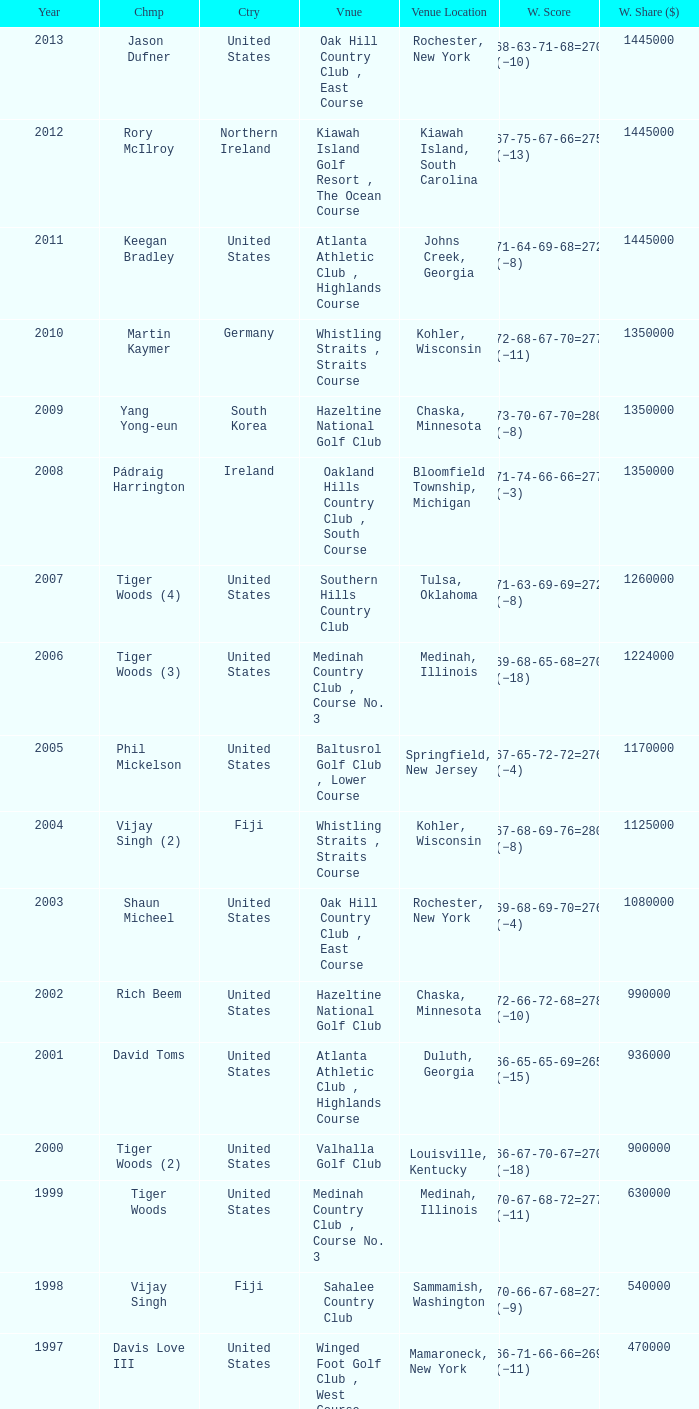Parse the table in full. {'header': ['Year', 'Chmp', 'Ctry', 'Vnue', 'Venue Location', 'W. Score', 'W. Share ($)'], 'rows': [['2013', 'Jason Dufner', 'United States', 'Oak Hill Country Club , East Course', 'Rochester, New York', '68-63-71-68=270 (−10)', '1445000'], ['2012', 'Rory McIlroy', 'Northern Ireland', 'Kiawah Island Golf Resort , The Ocean Course', 'Kiawah Island, South Carolina', '67-75-67-66=275 (−13)', '1445000'], ['2011', 'Keegan Bradley', 'United States', 'Atlanta Athletic Club , Highlands Course', 'Johns Creek, Georgia', '71-64-69-68=272 (−8)', '1445000'], ['2010', 'Martin Kaymer', 'Germany', 'Whistling Straits , Straits Course', 'Kohler, Wisconsin', '72-68-67-70=277 (−11)', '1350000'], ['2009', 'Yang Yong-eun', 'South Korea', 'Hazeltine National Golf Club', 'Chaska, Minnesota', '73-70-67-70=280 (−8)', '1350000'], ['2008', 'Pádraig Harrington', 'Ireland', 'Oakland Hills Country Club , South Course', 'Bloomfield Township, Michigan', '71-74-66-66=277 (−3)', '1350000'], ['2007', 'Tiger Woods (4)', 'United States', 'Southern Hills Country Club', 'Tulsa, Oklahoma', '71-63-69-69=272 (−8)', '1260000'], ['2006', 'Tiger Woods (3)', 'United States', 'Medinah Country Club , Course No. 3', 'Medinah, Illinois', '69-68-65-68=270 (−18)', '1224000'], ['2005', 'Phil Mickelson', 'United States', 'Baltusrol Golf Club , Lower Course', 'Springfield, New Jersey', '67-65-72-72=276 (−4)', '1170000'], ['2004', 'Vijay Singh (2)', 'Fiji', 'Whistling Straits , Straits Course', 'Kohler, Wisconsin', '67-68-69-76=280 (−8)', '1125000'], ['2003', 'Shaun Micheel', 'United States', 'Oak Hill Country Club , East Course', 'Rochester, New York', '69-68-69-70=276 (−4)', '1080000'], ['2002', 'Rich Beem', 'United States', 'Hazeltine National Golf Club', 'Chaska, Minnesota', '72-66-72-68=278 (−10)', '990000'], ['2001', 'David Toms', 'United States', 'Atlanta Athletic Club , Highlands Course', 'Duluth, Georgia', '66-65-65-69=265 (−15)', '936000'], ['2000', 'Tiger Woods (2)', 'United States', 'Valhalla Golf Club', 'Louisville, Kentucky', '66-67-70-67=270 (−18)', '900000'], ['1999', 'Tiger Woods', 'United States', 'Medinah Country Club , Course No. 3', 'Medinah, Illinois', '70-67-68-72=277 (−11)', '630000'], ['1998', 'Vijay Singh', 'Fiji', 'Sahalee Country Club', 'Sammamish, Washington', '70-66-67-68=271 (−9)', '540000'], ['1997', 'Davis Love III', 'United States', 'Winged Foot Golf Club , West Course', 'Mamaroneck, New York', '66-71-66-66=269 (−11)', '470000'], ['1996', 'Mark Brooks', 'United States', 'Valhalla Golf Club', 'Louisville, Kentucky', '68-70-69-70=277 (−11)', '430000'], ['1995', 'Steve Elkington', 'Australia', 'Riviera Country Club', 'Pacific Palisades, California', '68-67-68-64=267 (−17)', '360000'], ['1994', 'Nick Price (2)', 'Zimbabwe', 'Southern Hills Country Club', 'Tulsa, Oklahoma', '67-65-70-67=269 (−11)', '310000'], ['1993', 'Paul Azinger', 'United States', 'Inverness Club', 'Toledo, Ohio', '69-66-69-68=272 (−12)', '300000'], ['1992', 'Nick Price', 'Zimbabwe', 'Bellerive Country Club', 'St. Louis, Missouri', '70-70-68-70=278 (−6)', '280000'], ['1991', 'John Daly', 'United States', 'Crooked Stick Golf Club', 'Carmel, Indiana', '69-67-69-71=276 (−12)', '230000'], ['1990', 'Wayne Grady', 'Australia', 'Shoal Creek Golf and Country Club', 'Birmingham, Alabama', '72-67-72-71=282 (−6)', '225000'], ['1989', 'Payne Stewart', 'United States', 'Kemper Lakes Golf Club', 'Long Grove, Illinois', '74-66-69-67=276 (−12)', '200000'], ['1988', 'Jeff Sluman', 'United States', 'Oak Tree Golf Club', 'Edmond, Oklahoma', '69-70-68-65=272 (−12)', '160000'], ['1987', 'Larry Nelson (2)', 'United States', 'PGA National Resort & Spa', 'Palm Beach Gardens, Florida', '70-72-73-72=287 (−1)', '150000'], ['1986', 'Bob Tway', 'United States', 'Inverness Club', 'Toledo, Ohio', '72-70-64-70=276 (−8)', '145000'], ['1985', 'Hubert Green', 'United States', 'Cherry Hills Country Club', 'Cherry Hills Village, Colorado', '67-69-70-72=278 (−6)', '125000'], ['1984', 'Lee Trevino (2)', 'United States', 'Shoal Creek Golf and Country Club', 'Birmingham, Alabama', '69-68-67-69=273 (−15)', '125000'], ['1983', 'Hal Sutton', 'United States', 'Riviera Country Club', 'Pacific Palisades, California', '65-66-72-71=274 (−10)', '100000'], ['1982', 'Raymond Floyd (2)', 'United States', 'Southern Hills Country Club', 'Tulsa, Oklahoma', '63-69-68-72=272 (−8)', '65000'], ['1981', 'Larry Nelson', 'United States', 'Atlanta Athletic Club , Highlands Course', 'Duluth, Georgia', '70-66-66-71=273 (−7)', '60000'], ['1980', 'Jack Nicklaus (5)', 'United States', 'Oak Hill Country Club , East Course', 'Rochester, New York', '70-69-66-69=274 (−6)', '60000'], ['1979', 'David Graham', 'Australia', 'Oakland Hills Country Club , South Course', 'Bloomfield Township, Michigan', '69-68-70-65=272 (−8)', '60000'], ['1978', 'John Mahaffey', 'United States', 'Oakmont Country Club', 'Oakmont, Pennsylvania', '75-67-68-66=276 (−8)', '50000'], ['1977', 'Lanny Wadkins', 'United States', 'Pebble Beach Golf Links', 'Pebble Beach, California', '69-71-72-70=282 (−6)', '45000'], ['1976', 'Dave Stockton (2)', 'United States', 'Congressional Country Club , Blue Course', 'Bethesda, Maryland', '70-72-69-70=281 (+1)', '45000'], ['1975', 'Jack Nicklaus (4)', 'United States', 'Firestone Country Club , South Course', 'Akron, Ohio', '70-68-67-71=276 (−4)', '45000'], ['1974', 'Lee Trevino', 'United States', 'Tanglewood Park , Championship Course', 'Clemmons, North Carolina', '73-66-68-69=276 (−4)', '45000'], ['1973', 'Jack Nicklaus (3)', 'United States', 'Canterbury Golf Club', 'Beachwood, Ohio', '72-68-68-69=277 (−7)', '45000'], ['1972', 'Gary Player (2)', 'South Africa', 'Oakland Hills Country Club , South Course', 'Bloomfield Hills, Michigan', '71-71-67-72=281 (+1)', '45000'], ['1971', 'Jack Nicklaus (2)', 'United States', 'PGA National Golf Club', 'Palm Beach Gardens, Florida', '69-69-70-73=281 (−7)', '40000'], ['1970', 'Dave Stockton', 'United States', 'Southern Hills Country Club', 'Tulsa, Oklahoma', '70-70-66-73=279 (−1)', '40000'], ['1969', 'Raymond Floyd', 'United States', 'NCR Country Club , South Course', 'Dayton, Ohio', '69-66-67-74=276 (−8)', '35000'], ['1968', 'Julius Boros', 'United States', 'Pecan Valley Golf Club', 'San Antonio, Texas', '71-71-70-69=281 (+1)', '25000'], ['1967', 'Don January', 'United States', 'Columbine Country Club', 'Columbine Valley, Colorado', '71-72-70-68=281 (−7)', '25000'], ['1966', 'Al Geiberger', 'United States', 'Firestone Country Club , South Course', 'Akron, Ohio', '68-72-68-72=280 (E)', '25000'], ['1965', 'Dave Marr', 'United States', 'Laurel Valley Golf Club', 'Ligonier, Pennsylvania', '70-69-70-71=280 (−4)', '25000'], ['1964', 'Bobby Nichols', 'United States', 'Columbus Country Club', 'Columbus, Ohio', '64-71-69-67=271 (−9)', '18000'], ['1963', 'Jack Nicklaus', 'United States', 'Dallas Athletic Club , Blue Course', 'Dallas, Texas', '69-73-69-68=279 (−5)', '13000'], ['1962', 'Gary Player', 'South Africa', 'Aronimink Golf Club', 'Newtown Square, Pennsylvania', '72-67-69-70=278 (−2)', '13000'], ['1961', 'Jerry Barber', 'United States', 'Olympia Fields Country Club', 'Olympia Fields, Illinois', '69-67-71-70=277 (−3)', '11000'], ['1960', 'Jay Hebert', 'United States', 'Firestone Country Club , South Course', 'Akron, Ohio', '72-67-72-70=281 (+1)', '11000'], ['1959', 'Bob Rosburg', 'United States', 'Minneapolis Golf Club', 'Minneapolis, Minnesota', '71-72-68-66=277 (−3)', '8250']]} In which location is the bellerive country club venue positioned? St. Louis, Missouri. 